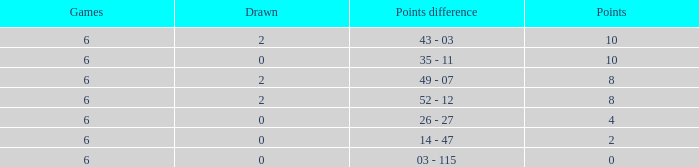What was the highest points where there were less than 2 drawn and the games were less than 6? None. Parse the table in full. {'header': ['Games', 'Drawn', 'Points difference', 'Points'], 'rows': [['6', '2', '43 - 03', '10'], ['6', '0', '35 - 11', '10'], ['6', '2', '49 - 07', '8'], ['6', '2', '52 - 12', '8'], ['6', '0', '26 - 27', '4'], ['6', '0', '14 - 47', '2'], ['6', '0', '03 - 115', '0']]} 